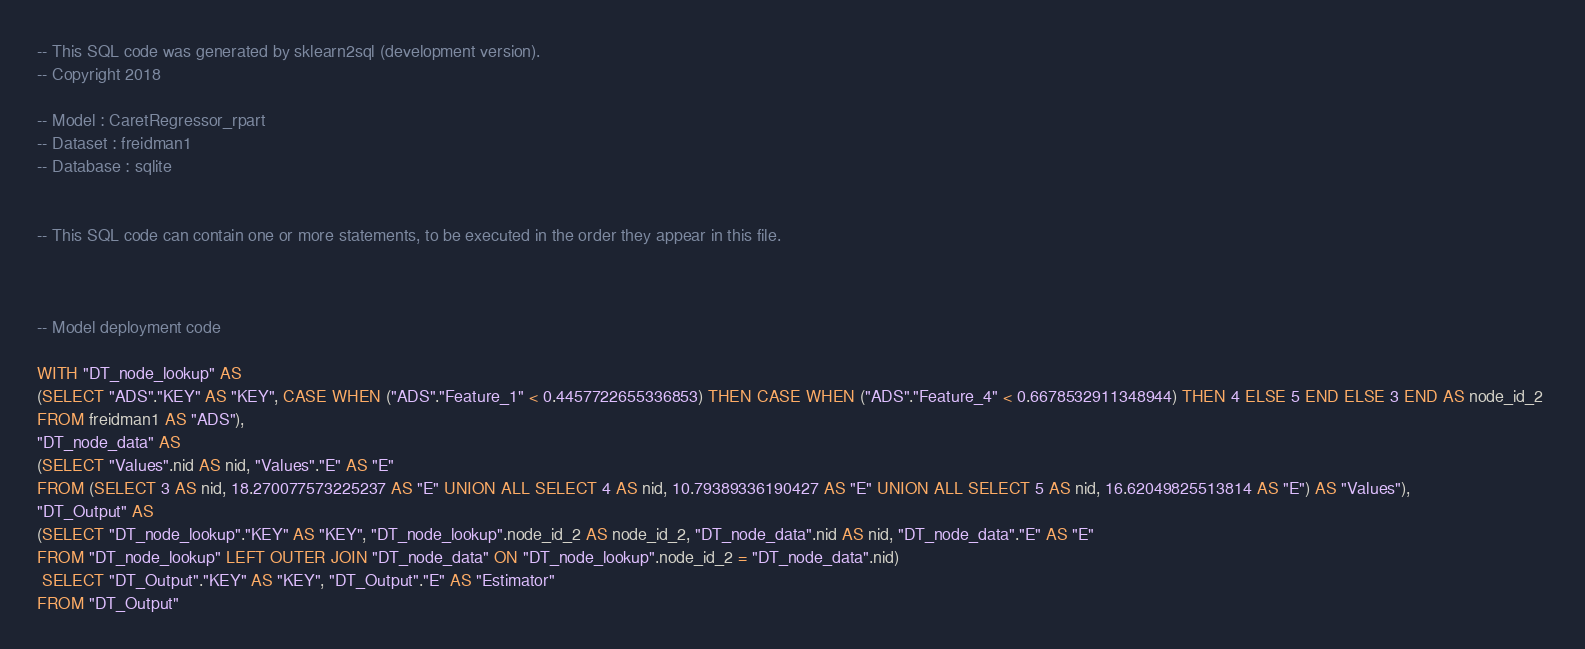Convert code to text. <code><loc_0><loc_0><loc_500><loc_500><_SQL_>-- This SQL code was generated by sklearn2sql (development version).
-- Copyright 2018

-- Model : CaretRegressor_rpart
-- Dataset : freidman1
-- Database : sqlite


-- This SQL code can contain one or more statements, to be executed in the order they appear in this file.



-- Model deployment code

WITH "DT_node_lookup" AS 
(SELECT "ADS"."KEY" AS "KEY", CASE WHEN ("ADS"."Feature_1" < 0.4457722655336853) THEN CASE WHEN ("ADS"."Feature_4" < 0.6678532911348944) THEN 4 ELSE 5 END ELSE 3 END AS node_id_2 
FROM freidman1 AS "ADS"), 
"DT_node_data" AS 
(SELECT "Values".nid AS nid, "Values"."E" AS "E" 
FROM (SELECT 3 AS nid, 18.270077573225237 AS "E" UNION ALL SELECT 4 AS nid, 10.79389336190427 AS "E" UNION ALL SELECT 5 AS nid, 16.62049825513814 AS "E") AS "Values"), 
"DT_Output" AS 
(SELECT "DT_node_lookup"."KEY" AS "KEY", "DT_node_lookup".node_id_2 AS node_id_2, "DT_node_data".nid AS nid, "DT_node_data"."E" AS "E" 
FROM "DT_node_lookup" LEFT OUTER JOIN "DT_node_data" ON "DT_node_lookup".node_id_2 = "DT_node_data".nid)
 SELECT "DT_Output"."KEY" AS "KEY", "DT_Output"."E" AS "Estimator" 
FROM "DT_Output"</code> 